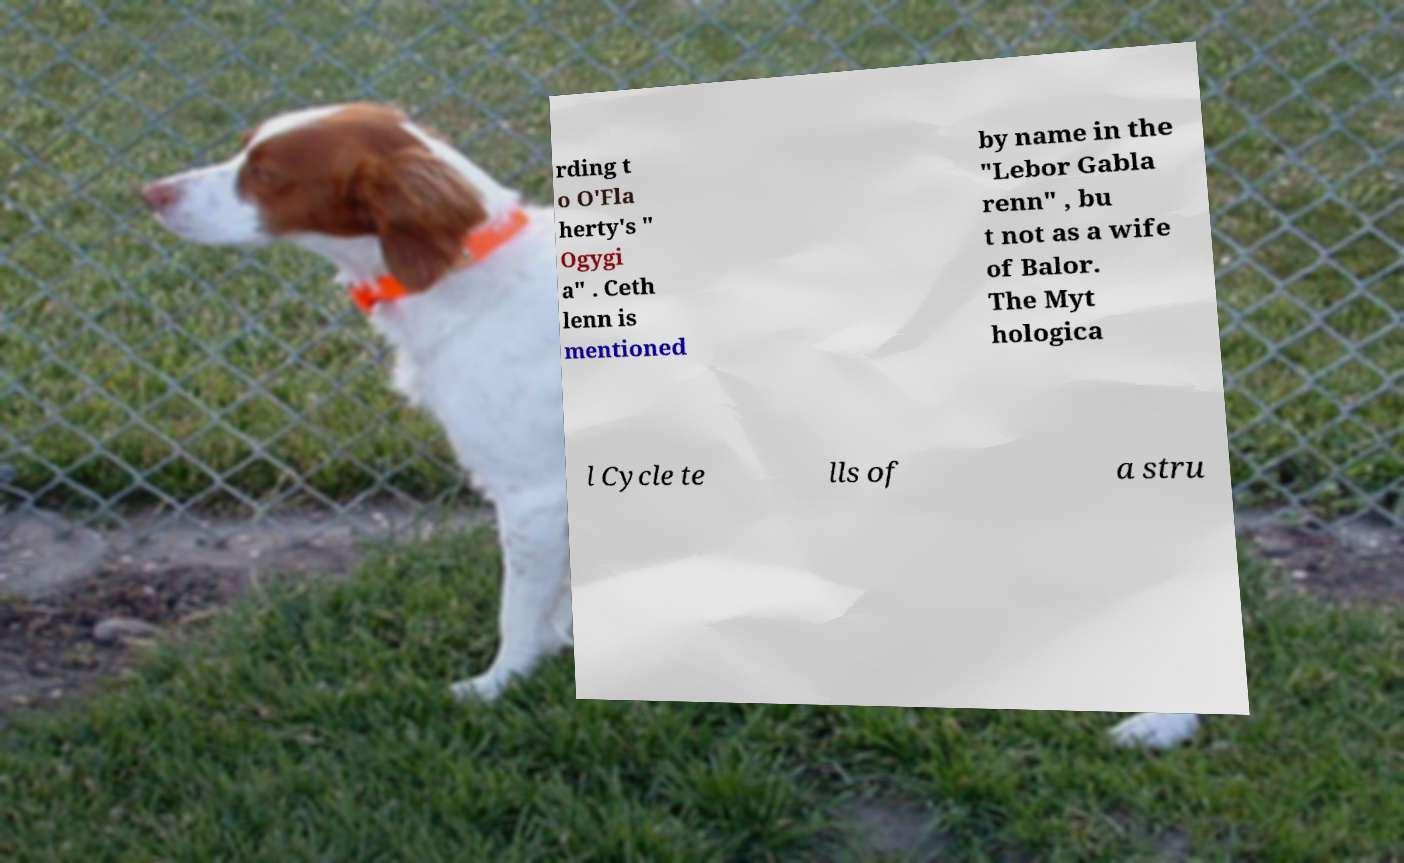Can you accurately transcribe the text from the provided image for me? rding t o O'Fla herty's " Ogygi a" . Ceth lenn is mentioned by name in the "Lebor Gabla renn" , bu t not as a wife of Balor. The Myt hologica l Cycle te lls of a stru 